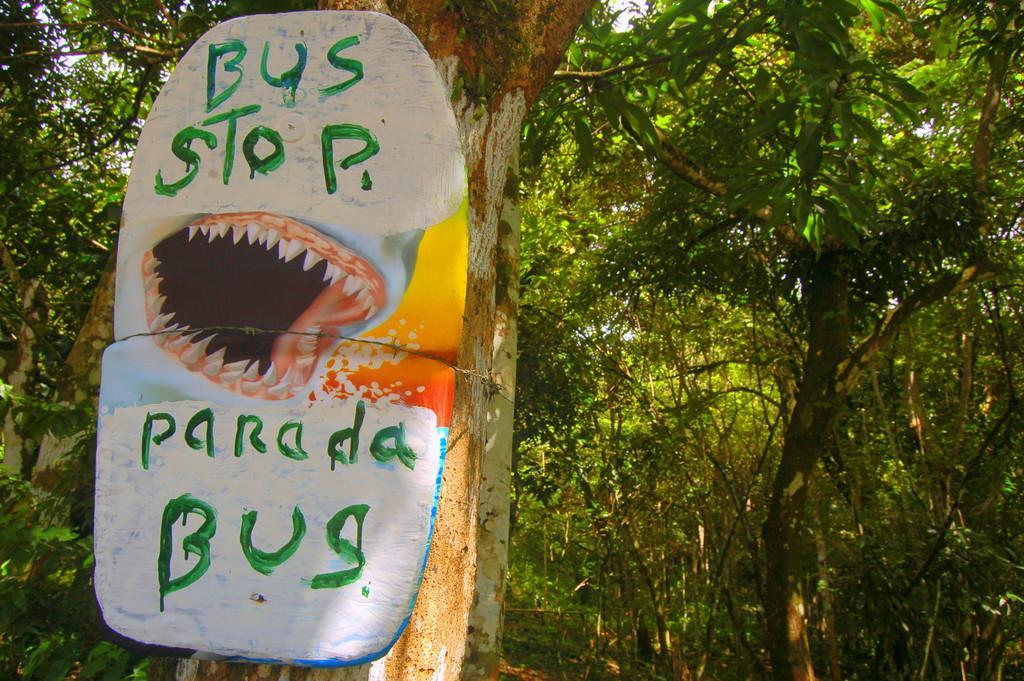In one or two sentences, can you explain what this image depicts? In the picture we can see a tree branch on it, we can see a board written on its bus stop- parada bus and with a teeth symbol and behind the tree branch we can see full of trees. 